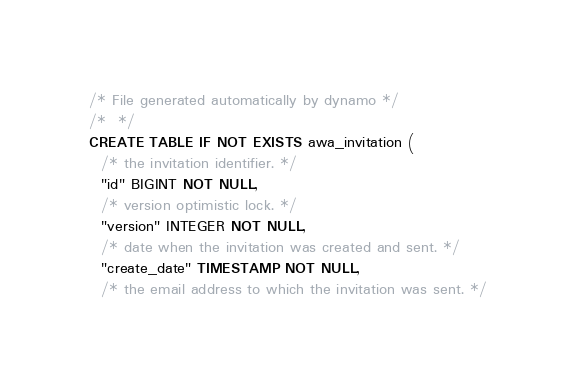Convert code to text. <code><loc_0><loc_0><loc_500><loc_500><_SQL_>/* File generated automatically by dynamo */
/*  */
CREATE TABLE IF NOT EXISTS awa_invitation (
  /* the invitation identifier. */
  "id" BIGINT NOT NULL,
  /* version optimistic lock. */
  "version" INTEGER NOT NULL,
  /* date when the invitation was created and sent. */
  "create_date" TIMESTAMP NOT NULL,
  /* the email address to which the invitation was sent. */</code> 